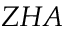<formula> <loc_0><loc_0><loc_500><loc_500>Z H A</formula> 